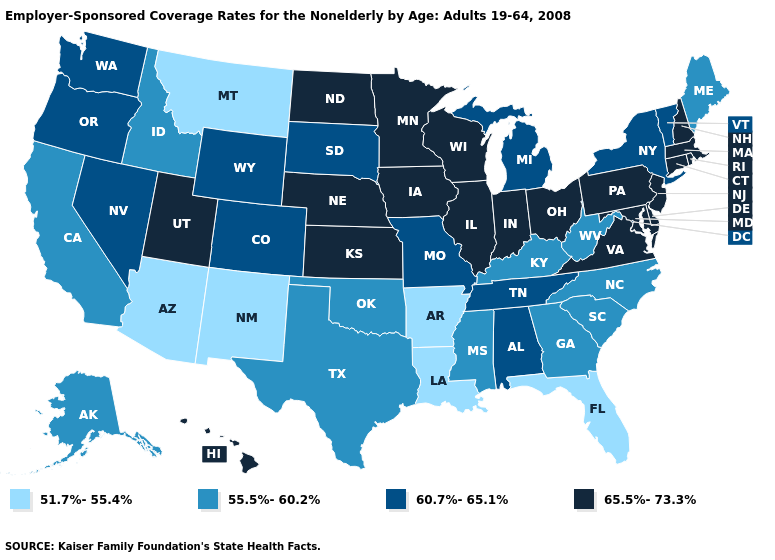Among the states that border Oregon , which have the highest value?
Keep it brief. Nevada, Washington. Does the first symbol in the legend represent the smallest category?
Quick response, please. Yes. What is the highest value in the USA?
Answer briefly. 65.5%-73.3%. Name the states that have a value in the range 65.5%-73.3%?
Short answer required. Connecticut, Delaware, Hawaii, Illinois, Indiana, Iowa, Kansas, Maryland, Massachusetts, Minnesota, Nebraska, New Hampshire, New Jersey, North Dakota, Ohio, Pennsylvania, Rhode Island, Utah, Virginia, Wisconsin. What is the value of Iowa?
Quick response, please. 65.5%-73.3%. Does Utah have a higher value than Georgia?
Give a very brief answer. Yes. Does South Dakota have the lowest value in the USA?
Concise answer only. No. Which states have the lowest value in the USA?
Keep it brief. Arizona, Arkansas, Florida, Louisiana, Montana, New Mexico. Name the states that have a value in the range 60.7%-65.1%?
Quick response, please. Alabama, Colorado, Michigan, Missouri, Nevada, New York, Oregon, South Dakota, Tennessee, Vermont, Washington, Wyoming. What is the value of Delaware?
Keep it brief. 65.5%-73.3%. Name the states that have a value in the range 51.7%-55.4%?
Quick response, please. Arizona, Arkansas, Florida, Louisiana, Montana, New Mexico. What is the value of Delaware?
Be succinct. 65.5%-73.3%. Among the states that border Arkansas , which have the highest value?
Be succinct. Missouri, Tennessee. Does Mississippi have a higher value than New York?
Be succinct. No. Does South Dakota have a higher value than North Carolina?
Give a very brief answer. Yes. 